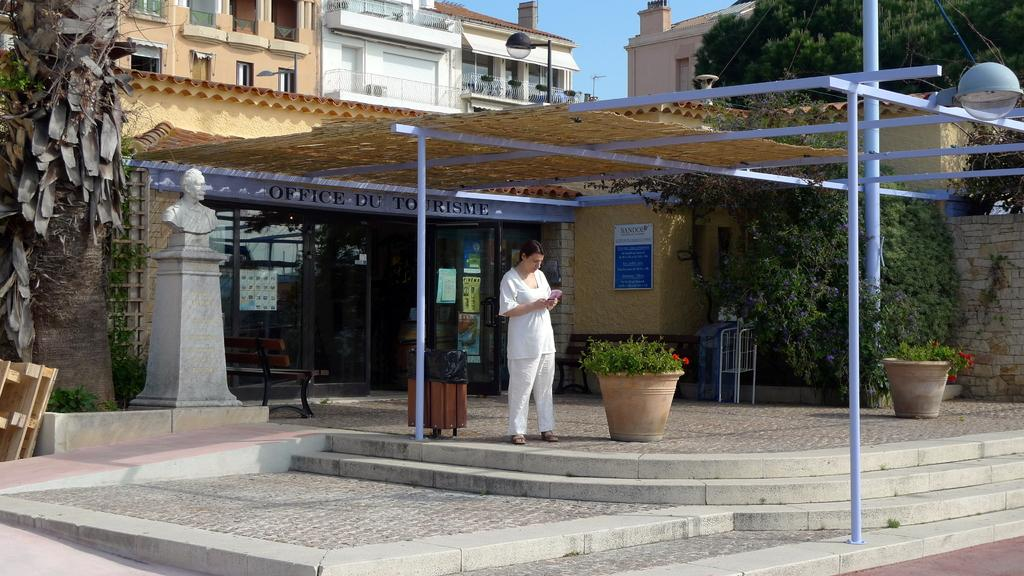What type of structures are present in the image? The image contains buildings. Can you describe the woman in the image? There is a woman wearing a white dress in the image, and she is stunning. What is located to the right of the image? There is a tree to the right of the image. What can be found to the left of the image? There are wooden benches to the left of the image. Can you see any airplanes taking off or landing at the airport in the image? There is no airport present in the image, so it is not possible to see any airplanes taking off or landing. How many birds are in the flock flying over the tree in the image? There is no flock of birds present in the image; only a tree is visible to the right. 